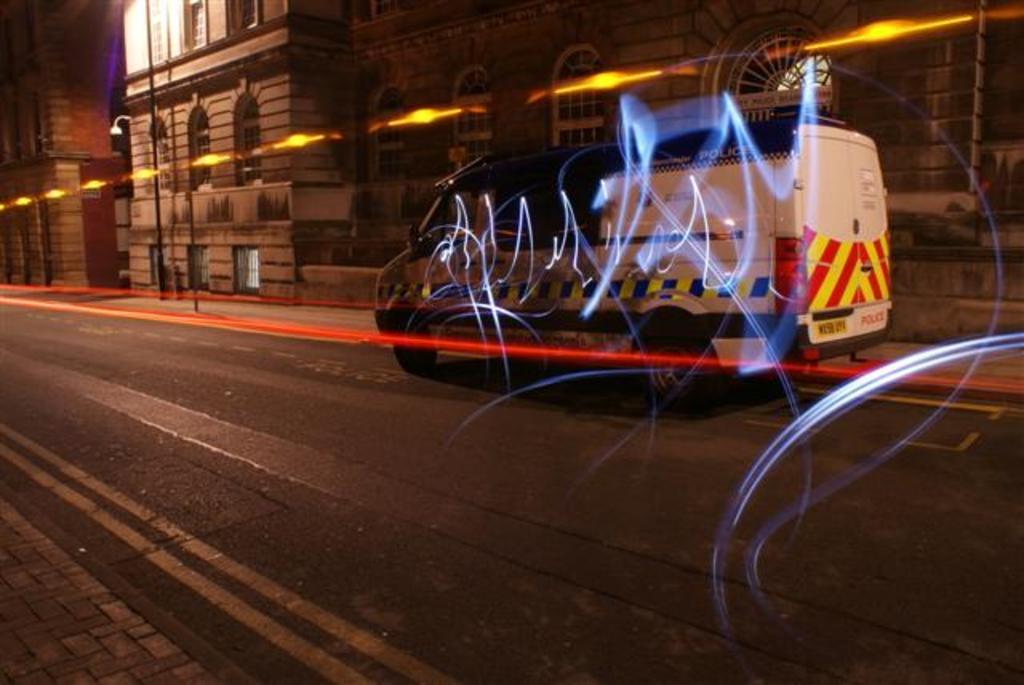Can you describe this image briefly? In this image I can see the road in front, on which there is a van and I can see the lights. In the background I can see the buildings and a pole. 